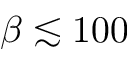Convert formula to latex. <formula><loc_0><loc_0><loc_500><loc_500>\beta \lesssim 1 0 0</formula> 